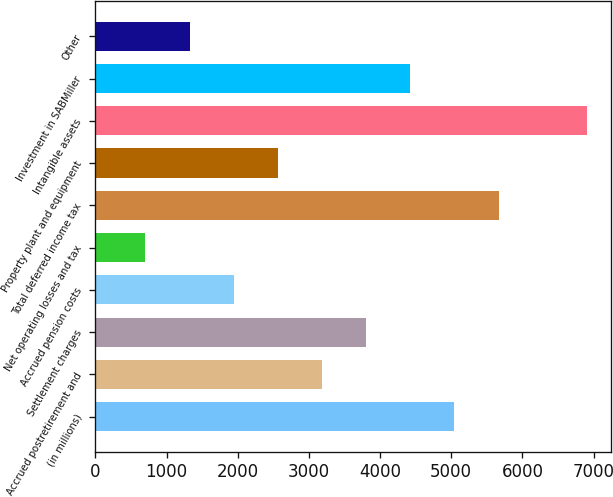Convert chart. <chart><loc_0><loc_0><loc_500><loc_500><bar_chart><fcel>(in millions)<fcel>Accrued postretirement and<fcel>Settlement charges<fcel>Accrued pension costs<fcel>Net operating losses and tax<fcel>Total deferred income tax<fcel>Property plant and equipment<fcel>Intangible assets<fcel>Investment in SABMiller<fcel>Other<nl><fcel>5045.2<fcel>3184<fcel>3804.4<fcel>1943.2<fcel>702.4<fcel>5665.6<fcel>2563.6<fcel>6906.4<fcel>4424.8<fcel>1322.8<nl></chart> 